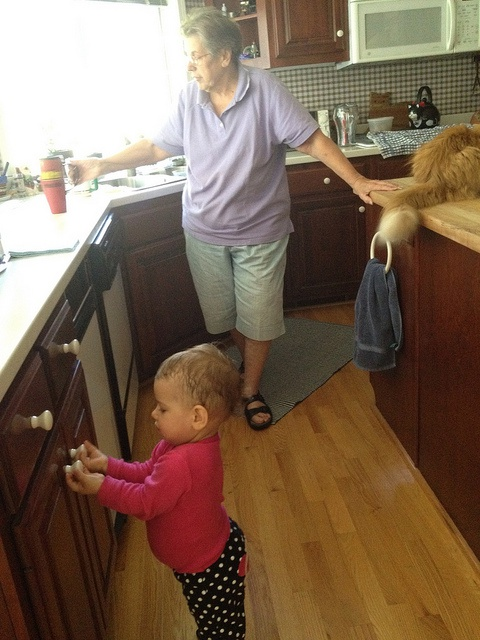Describe the objects in this image and their specific colors. I can see people in white, darkgray, gray, and lightgray tones, people in white, maroon, black, and brown tones, cat in white, olive, and tan tones, microwave in white, gray, beige, and tan tones, and cup in white, gray, darkgray, and darkgreen tones in this image. 